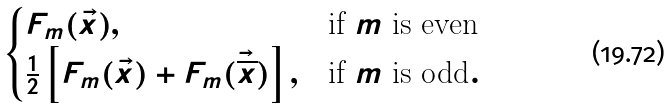Convert formula to latex. <formula><loc_0><loc_0><loc_500><loc_500>\begin{cases} F _ { m } ( \vec { x } ) , & \text {if $m$ is even} \\ \frac { 1 } { 2 } \left [ F _ { m } ( \vec { x } ) + F _ { m } ( { \vec { \overline { x } } } ) \right ] , & \text {if $m$ is odd} . \end{cases}</formula> 